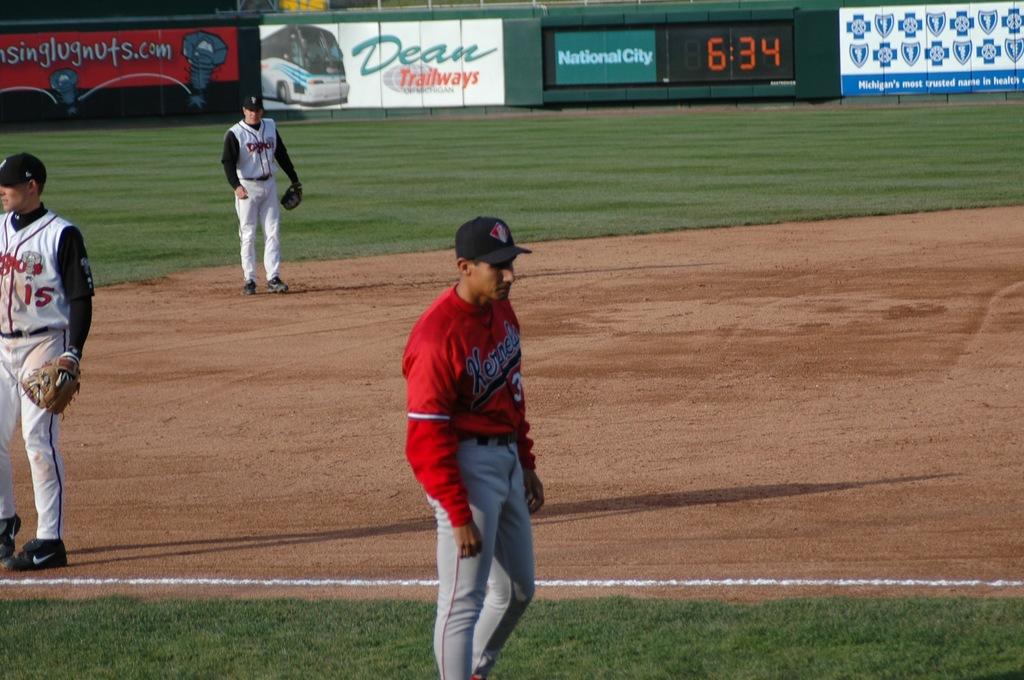What transportation company is a sponsor?
Offer a terse response. Dean trailways. 